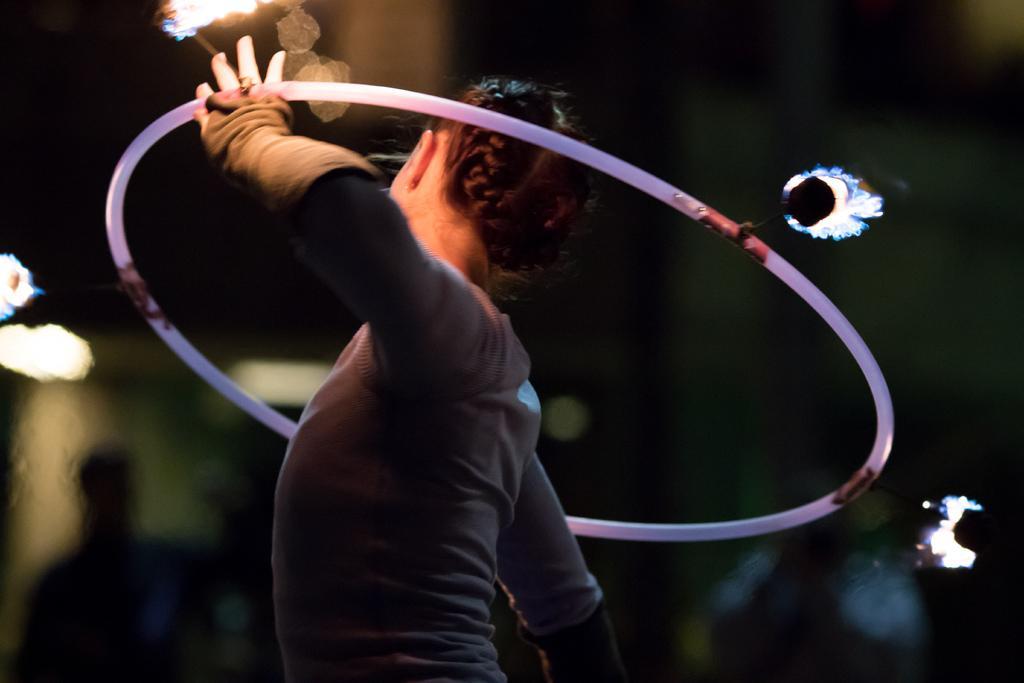In one or two sentences, can you explain what this image depicts? In the middle of the image a person is standing and holding a ring. Background of the image is blur. 